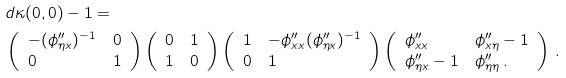<formula> <loc_0><loc_0><loc_500><loc_500>& d \kappa ( 0 , 0 ) - 1 = \\ & \left ( \begin{array} { l l } - ( \phi _ { \eta x } ^ { \prime \prime } ) ^ { - 1 } & 0 \\ 0 & 1 \end{array} \right ) \left ( \begin{array} { l l } 0 & 1 \\ 1 & 0 \end{array} \right ) \left ( \begin{array} { l l } 1 & - \phi ^ { \prime \prime } _ { x x } ( \phi ^ { \prime \prime } _ { \eta x } ) ^ { - 1 } \\ 0 & 1 \end{array} \right ) \left ( \begin{array} { l l } \phi ^ { \prime \prime } _ { x x } & \phi ^ { \prime \prime } _ { x \eta } - 1 \\ \phi ^ { \prime \prime } _ { \eta x } - 1 & \phi ^ { \prime \prime } _ { \eta \eta } \, . \end{array} \right ) \, .</formula> 